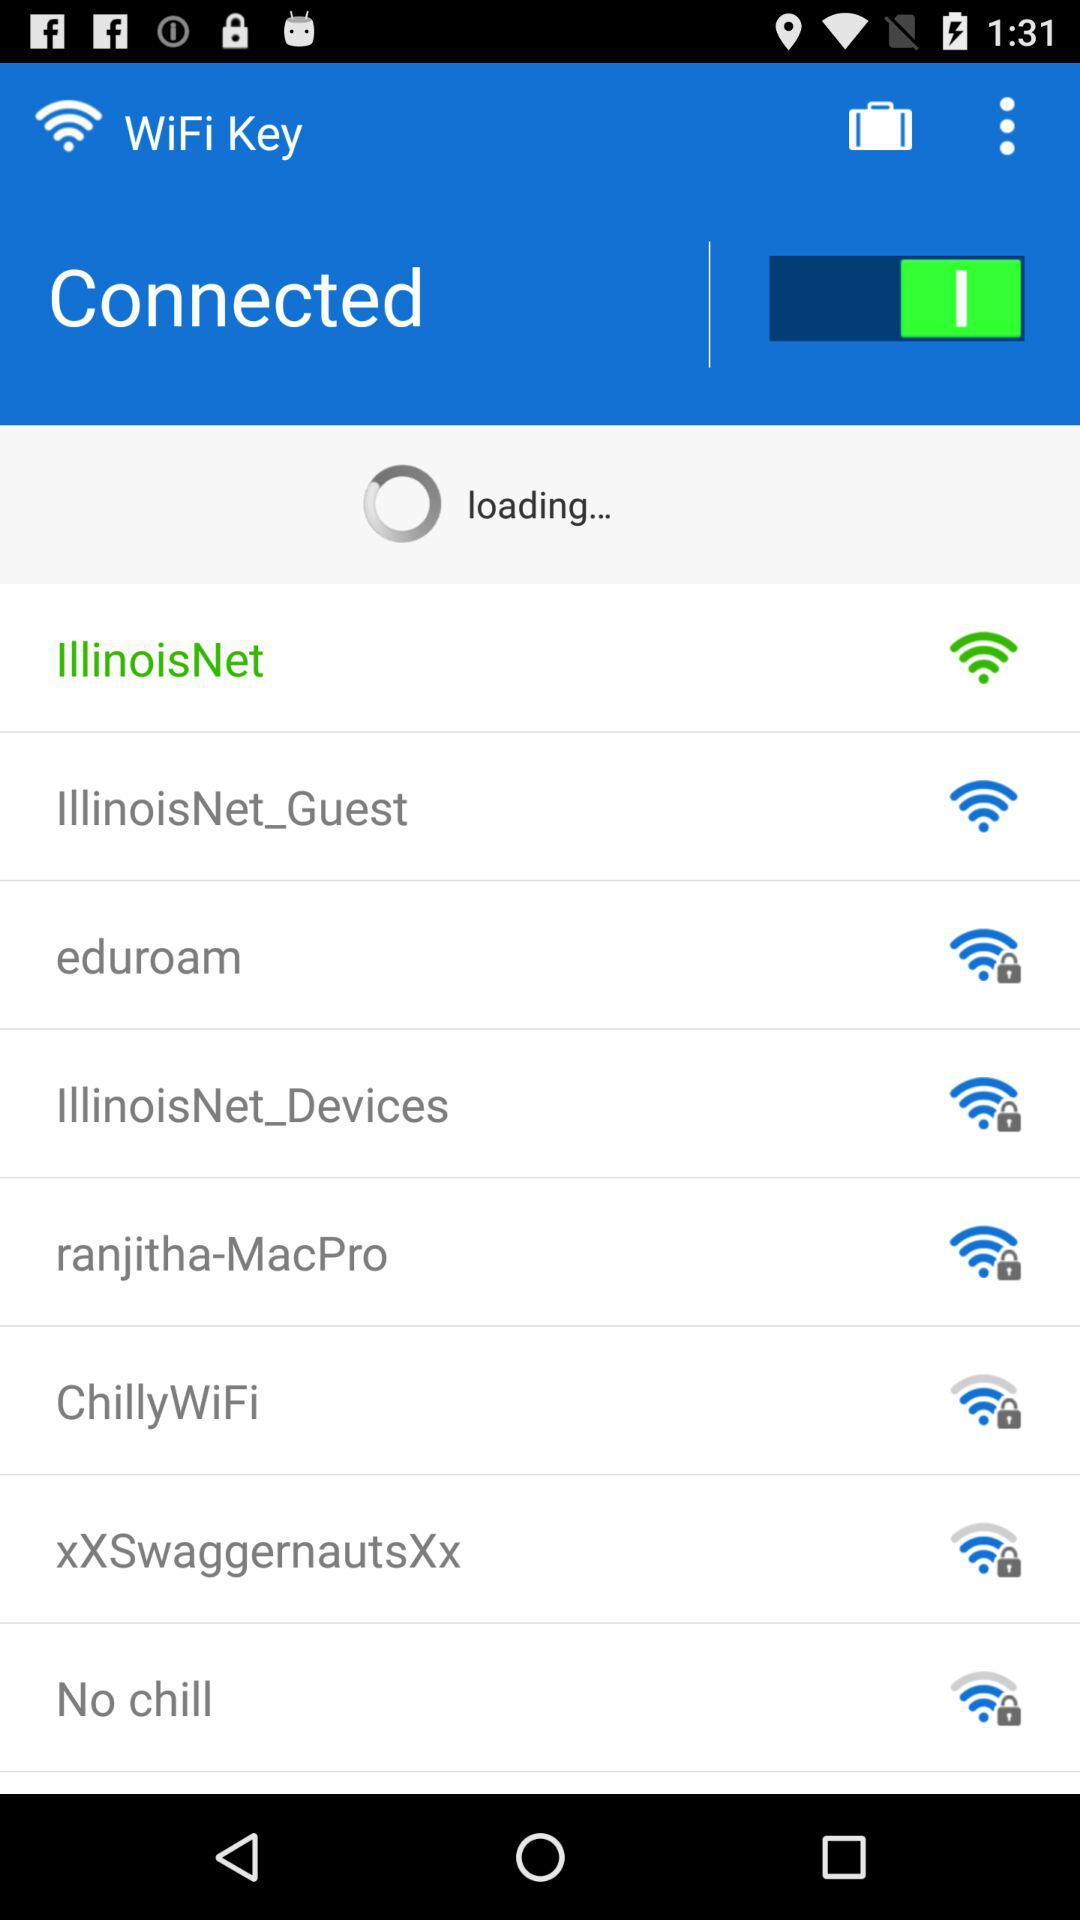What is the name of the WiFi that has been unlocked? The names of the WiFis that have been unlocked are "IllinoisNet" and "IllinoisNet_Guest". 